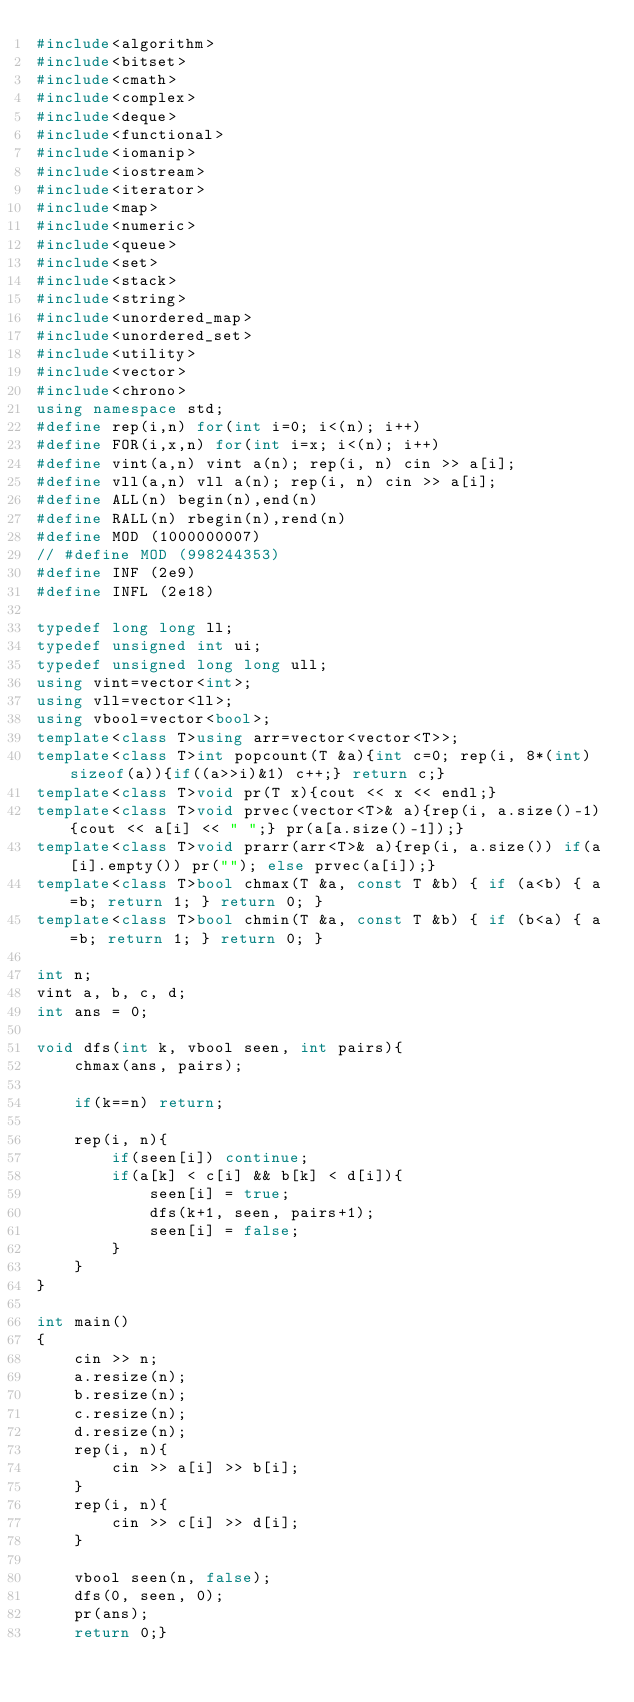<code> <loc_0><loc_0><loc_500><loc_500><_C++_>#include<algorithm>
#include<bitset>
#include<cmath>
#include<complex>
#include<deque>
#include<functional>
#include<iomanip>
#include<iostream>
#include<iterator>
#include<map>
#include<numeric>
#include<queue>
#include<set>
#include<stack>
#include<string>
#include<unordered_map>
#include<unordered_set>
#include<utility>
#include<vector>
#include<chrono>
using namespace std;
#define rep(i,n) for(int i=0; i<(n); i++)
#define FOR(i,x,n) for(int i=x; i<(n); i++)
#define vint(a,n) vint a(n); rep(i, n) cin >> a[i];
#define vll(a,n) vll a(n); rep(i, n) cin >> a[i];
#define ALL(n) begin(n),end(n)
#define RALL(n) rbegin(n),rend(n)
#define MOD (1000000007)
// #define MOD (998244353)
#define INF (2e9)
#define INFL (2e18)

typedef long long ll;
typedef unsigned int ui;
typedef unsigned long long ull;
using vint=vector<int>;
using vll=vector<ll>;
using vbool=vector<bool>;
template<class T>using arr=vector<vector<T>>;
template<class T>int popcount(T &a){int c=0; rep(i, 8*(int)sizeof(a)){if((a>>i)&1) c++;} return c;}
template<class T>void pr(T x){cout << x << endl;}
template<class T>void prvec(vector<T>& a){rep(i, a.size()-1){cout << a[i] << " ";} pr(a[a.size()-1]);}
template<class T>void prarr(arr<T>& a){rep(i, a.size()) if(a[i].empty()) pr(""); else prvec(a[i]);}
template<class T>bool chmax(T &a, const T &b) { if (a<b) { a=b; return 1; } return 0; }
template<class T>bool chmin(T &a, const T &b) { if (b<a) { a=b; return 1; } return 0; }

int n;
vint a, b, c, d;
int ans = 0;

void dfs(int k, vbool seen, int pairs){
    chmax(ans, pairs);

    if(k==n) return;

    rep(i, n){
        if(seen[i]) continue;
        if(a[k] < c[i] && b[k] < d[i]){
            seen[i] = true;
            dfs(k+1, seen, pairs+1);
            seen[i] = false;
        }
    }
}

int main()
{
    cin >> n;
    a.resize(n);
    b.resize(n);
    c.resize(n);
    d.resize(n);
    rep(i, n){
        cin >> a[i] >> b[i];
    }
    rep(i, n){
        cin >> c[i] >> d[i];
    }

    vbool seen(n, false);
    dfs(0, seen, 0);
    pr(ans);
    return 0;}</code> 